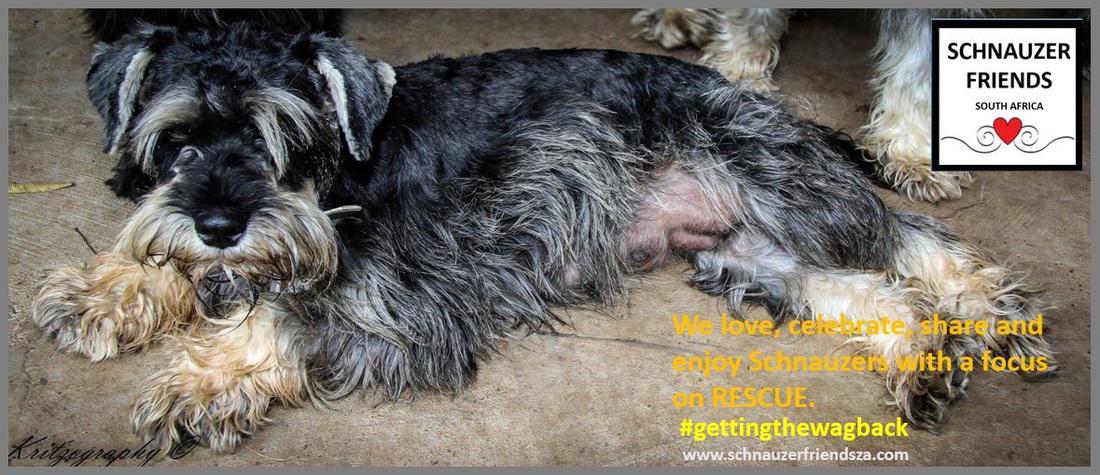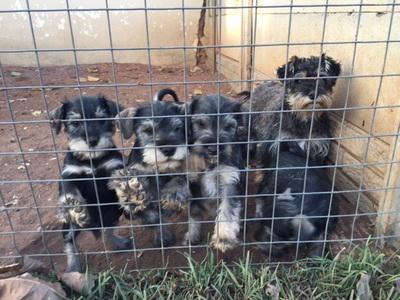The first image is the image on the left, the second image is the image on the right. Given the left and right images, does the statement "At least 4 dogs are standing behind a fence looking out." hold true? Answer yes or no. Yes. 